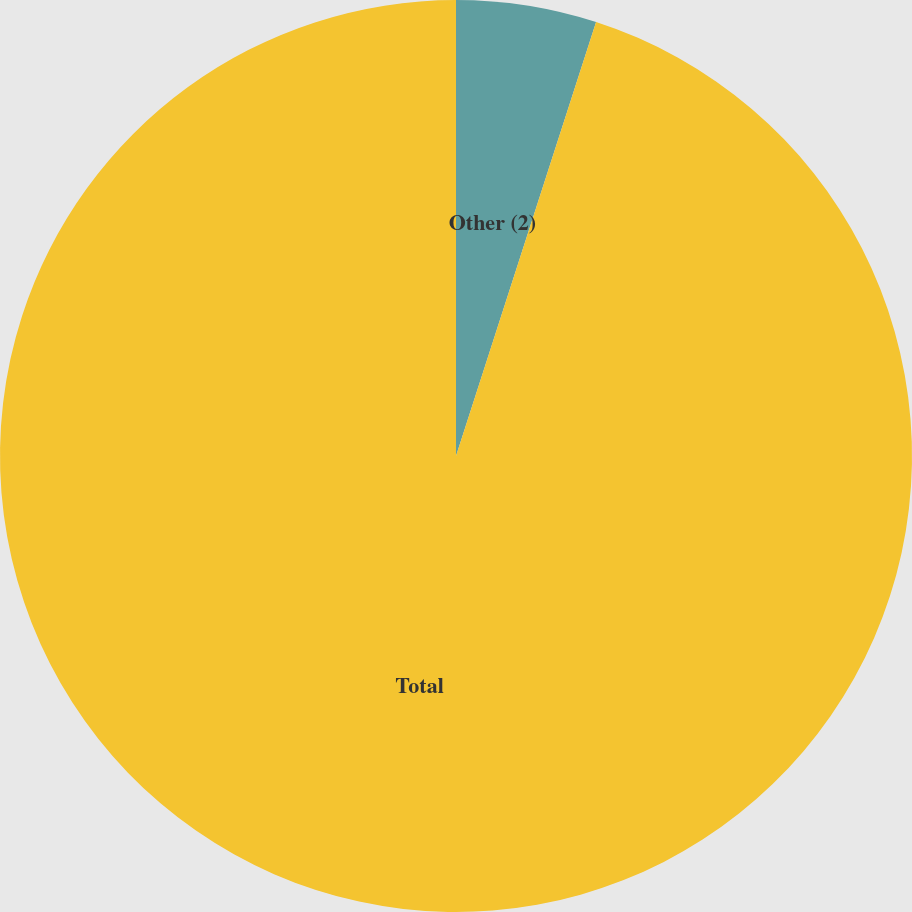Convert chart. <chart><loc_0><loc_0><loc_500><loc_500><pie_chart><fcel>Other (2)<fcel>Total<nl><fcel>4.97%<fcel>95.03%<nl></chart> 